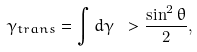<formula> <loc_0><loc_0><loc_500><loc_500>\gamma _ { t r a n s } = \int d \gamma \ > \frac { \sin ^ { 2 } \theta } { 2 } ,</formula> 